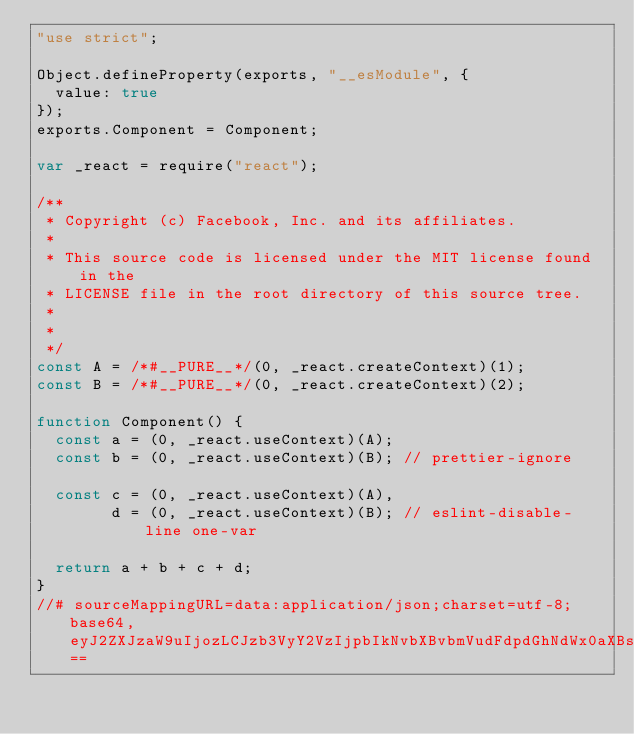Convert code to text. <code><loc_0><loc_0><loc_500><loc_500><_JavaScript_>"use strict";

Object.defineProperty(exports, "__esModule", {
  value: true
});
exports.Component = Component;

var _react = require("react");

/**
 * Copyright (c) Facebook, Inc. and its affiliates.
 *
 * This source code is licensed under the MIT license found in the
 * LICENSE file in the root directory of this source tree.
 *
 * 
 */
const A = /*#__PURE__*/(0, _react.createContext)(1);
const B = /*#__PURE__*/(0, _react.createContext)(2);

function Component() {
  const a = (0, _react.useContext)(A);
  const b = (0, _react.useContext)(B); // prettier-ignore

  const c = (0, _react.useContext)(A),
        d = (0, _react.useContext)(B); // eslint-disable-line one-var

  return a + b + c + d;
}
//# sourceMappingURL=data:application/json;charset=utf-8;base64,eyJ2ZXJzaW9uIjozLCJzb3VyY2VzIjpbIkNvbXBvbmVudFdpdGhNdWx0aXBsZUhvb2tzUGVyTGluZS5qcyJdLCJuYW1lcyI6WyJBIiwiQiIsIkNvbXBvbmVudCIsImEiLCJiIiwiYyIsImQiXSwibWFwcGluZ3MiOiI7Ozs7Ozs7QUFTQTs7QUFUQTs7Ozs7Ozs7QUFXQSxNQUFNQSxDQUFDLGdCQUFHLDBCQUFjLENBQWQsQ0FBVjtBQUNBLE1BQU1DLENBQUMsZ0JBQUcsMEJBQWMsQ0FBZCxDQUFWOztBQUVPLFNBQVNDLFNBQVQsR0FBcUI7QUFDMUIsUUFBTUMsQ0FBQyxHQUFHLHVCQUFXSCxDQUFYLENBQVY7QUFDQSxRQUFNSSxDQUFDLEdBQUcsdUJBQVdILENBQVgsQ0FBVixDQUYwQixDQUkxQjs7QUFDQSxRQUFNSSxDQUFDLEdBQUcsdUJBQVdMLENBQVgsQ0FBVjtBQUFBLFFBQXlCTSxDQUFDLEdBQUcsdUJBQVdMLENBQVgsQ0FBN0IsQ0FMMEIsQ0FLa0I7O0FBRTVDLFNBQU9FLENBQUMsR0FBR0MsQ0FBSixHQUFRQyxDQUFSLEdBQVlDLENBQW5CO0FBQ0QiLCJzb3VyY2VzQ29udGVudCI6WyIvKipcbiAqIENvcHlyaWdodCAoYykgRmFjZWJvb2ssIEluYy4gYW5kIGl0cyBhZmZpbGlhdGVzLlxuICpcbiAqIFRoaXMgc291cmNlIGNvZGUgaXMgbGljZW5zZWQgdW5kZXIgdGhlIE1JVCBsaWNlbnNlIGZvdW5kIGluIHRoZVxuICogTElDRU5TRSBmaWxlIGluIHRoZSByb290IGRpcmVjdG9yeSBvZiB0aGlzIHNvdXJjZSB0cmVlLlxuICpcbiAqIEBmbG93XG4gKi9cblxuaW1wb3J0IHtjcmVhdGVDb250ZXh0LCB1c2VDb250ZXh0fSBmcm9tICdyZWFjdCc7XG5cbmNvbnN0IEEgPSBjcmVhdGVDb250ZXh0KDEpO1xuY29uc3QgQiA9IGNyZWF0ZUNvbnRleHQoMik7XG5cbmV4cG9ydCBmdW5jdGlvbiBDb21wb25lbnQoKSB7XG4gIGNvbnN0IGEgPSB1c2VDb250ZXh0KEEpO1xuICBjb25zdCBiID0gdXNlQ29udGV4dChCKTtcblxuICAvLyBwcmV0dGllci1pZ25vcmVcbiAgY29uc3QgYyA9IHVzZUNvbnRleHQoQSksIGQgPSB1c2VDb250ZXh0KEIpOyAvLyBlc2xpbnQtZGlzYWJsZS1saW5lIG9uZS12YXJcblxuICByZXR1cm4gYSArIGIgKyBjICsgZDtcbn1cbiJdfQ==</code> 